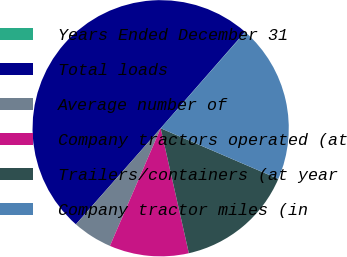<chart> <loc_0><loc_0><loc_500><loc_500><pie_chart><fcel>Years Ended December 31<fcel>Total loads<fcel>Average number of<fcel>Company tractors operated (at<fcel>Trailers/containers (at year<fcel>Company tractor miles (in<nl><fcel>0.04%<fcel>49.93%<fcel>5.03%<fcel>10.01%<fcel>15.0%<fcel>19.99%<nl></chart> 